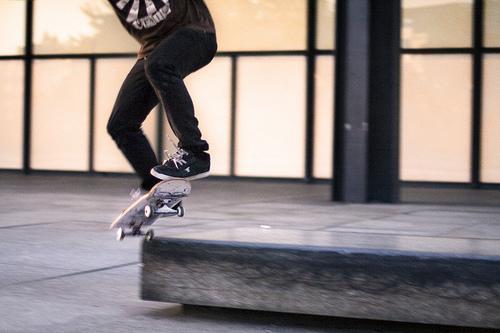How many red skateboards are there?
Give a very brief answer. 0. 